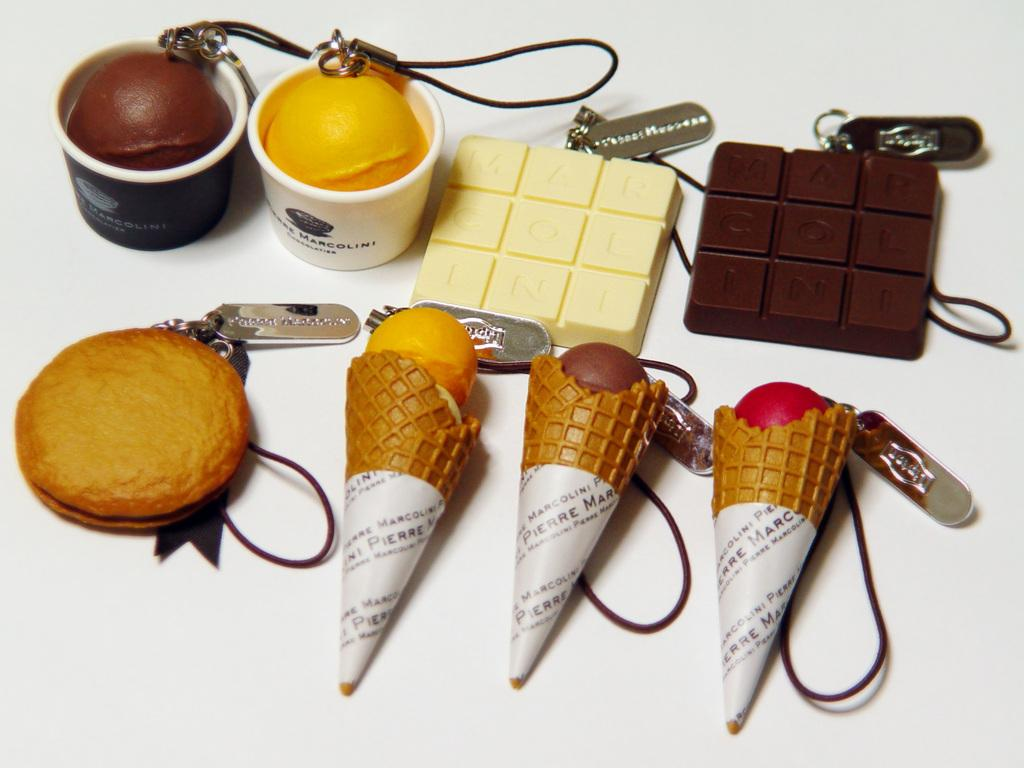What types of desserts are depicted in the image? There are depictions of ice cream and chocolates in the image. Are there any words or letters present in the image? Yes, there is writing on some items in the image. What type of silk is being used to make the chicken in the image? There is no chicken or silk present in the image; it only features depictions of ice cream and chocolates with writing on some items. 